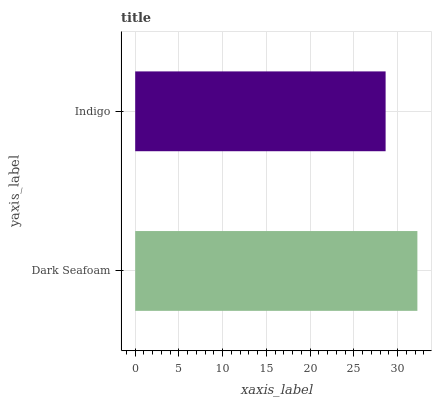Is Indigo the minimum?
Answer yes or no. Yes. Is Dark Seafoam the maximum?
Answer yes or no. Yes. Is Indigo the maximum?
Answer yes or no. No. Is Dark Seafoam greater than Indigo?
Answer yes or no. Yes. Is Indigo less than Dark Seafoam?
Answer yes or no. Yes. Is Indigo greater than Dark Seafoam?
Answer yes or no. No. Is Dark Seafoam less than Indigo?
Answer yes or no. No. Is Dark Seafoam the high median?
Answer yes or no. Yes. Is Indigo the low median?
Answer yes or no. Yes. Is Indigo the high median?
Answer yes or no. No. Is Dark Seafoam the low median?
Answer yes or no. No. 